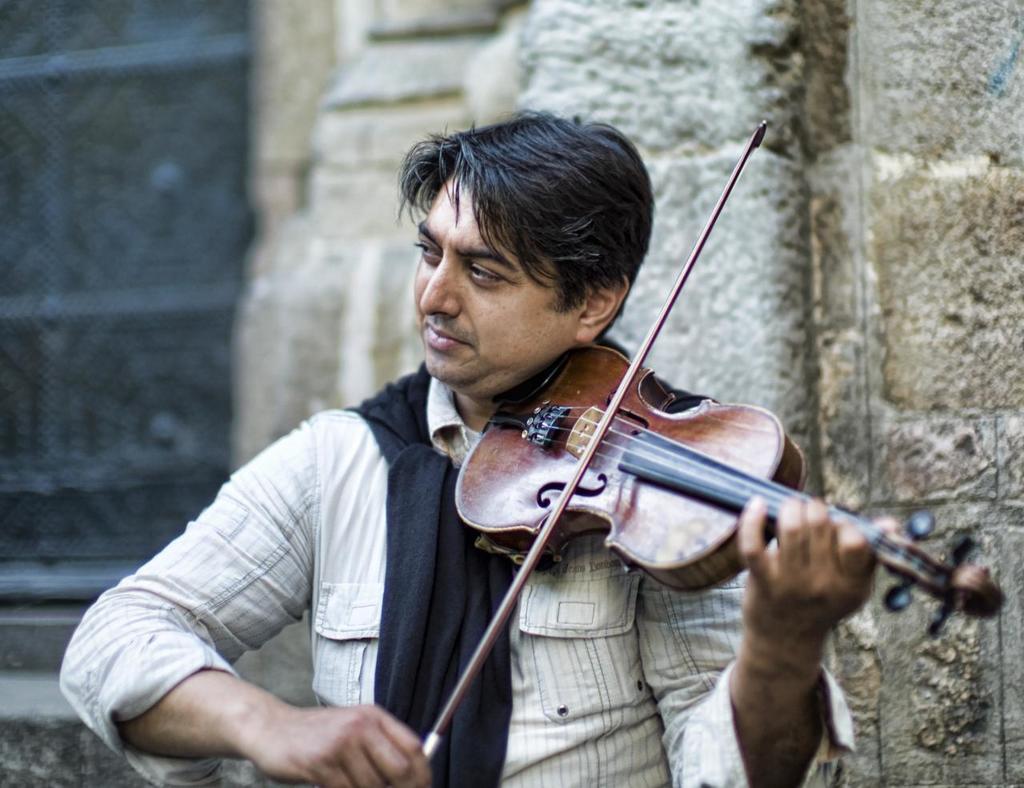Could you give a brief overview of what you see in this image? Here I can see a man playing a violin by looking at the left side. In the background there is a wall. He is wearing a shirt and a black color scarf around the neck. 